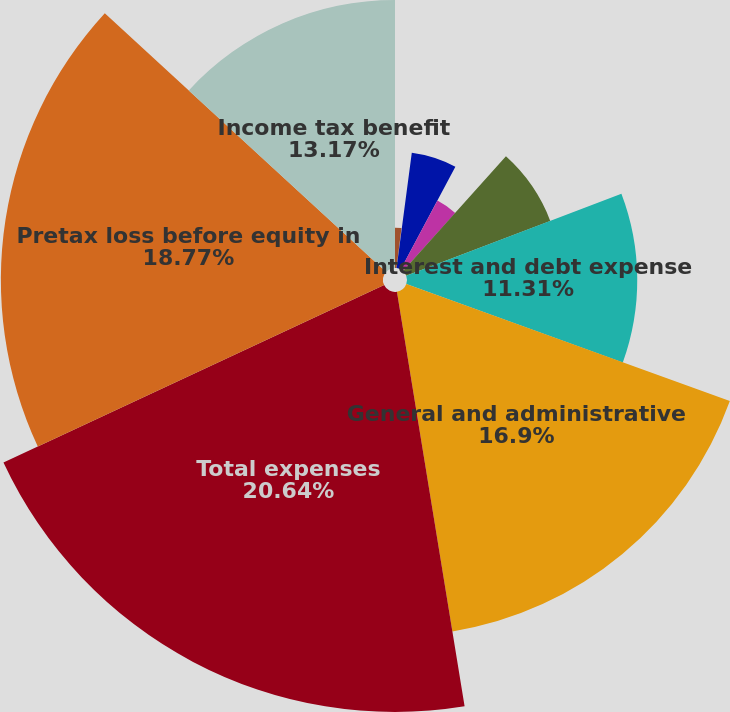Convert chart to OTSL. <chart><loc_0><loc_0><loc_500><loc_500><pie_chart><fcel>Net investment income<fcel>Other revenues<fcel>Total revenues<fcel>Total net revenues<fcel>Benefits claims losses and<fcel>Interest and debt expense<fcel>General and administrative<fcel>Total expenses<fcel>Pretax loss before equity in<fcel>Income tax benefit<nl><fcel>1.98%<fcel>0.11%<fcel>5.71%<fcel>3.84%<fcel>7.57%<fcel>11.31%<fcel>16.9%<fcel>20.63%<fcel>18.77%<fcel>13.17%<nl></chart> 